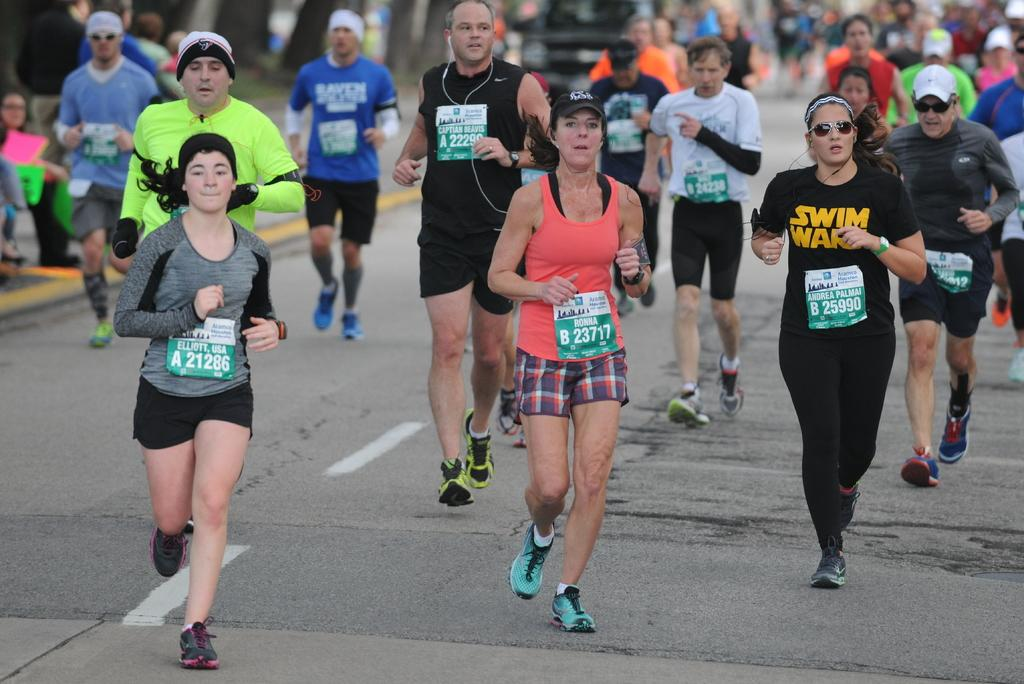What are the people in the image doing? The people in the image are running. Where are the people running? The people are running on a road. Can you describe the background of the image? The background appears blurry. What type of harmony is being played by the army in the image? There is no army or harmony present in the image; it features people running on a road with a blurry background. 